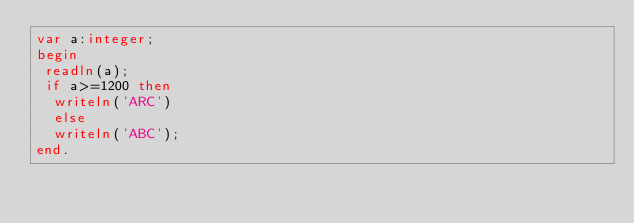<code> <loc_0><loc_0><loc_500><loc_500><_Pascal_>var a:integer;
begin
 readln(a);
 if a>=1200 then
  writeln('ARC')
  else
  writeln('ABC');
end.  </code> 